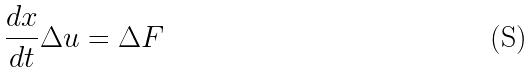Convert formula to latex. <formula><loc_0><loc_0><loc_500><loc_500>\frac { d x } { d t } \Delta u = \Delta F</formula> 